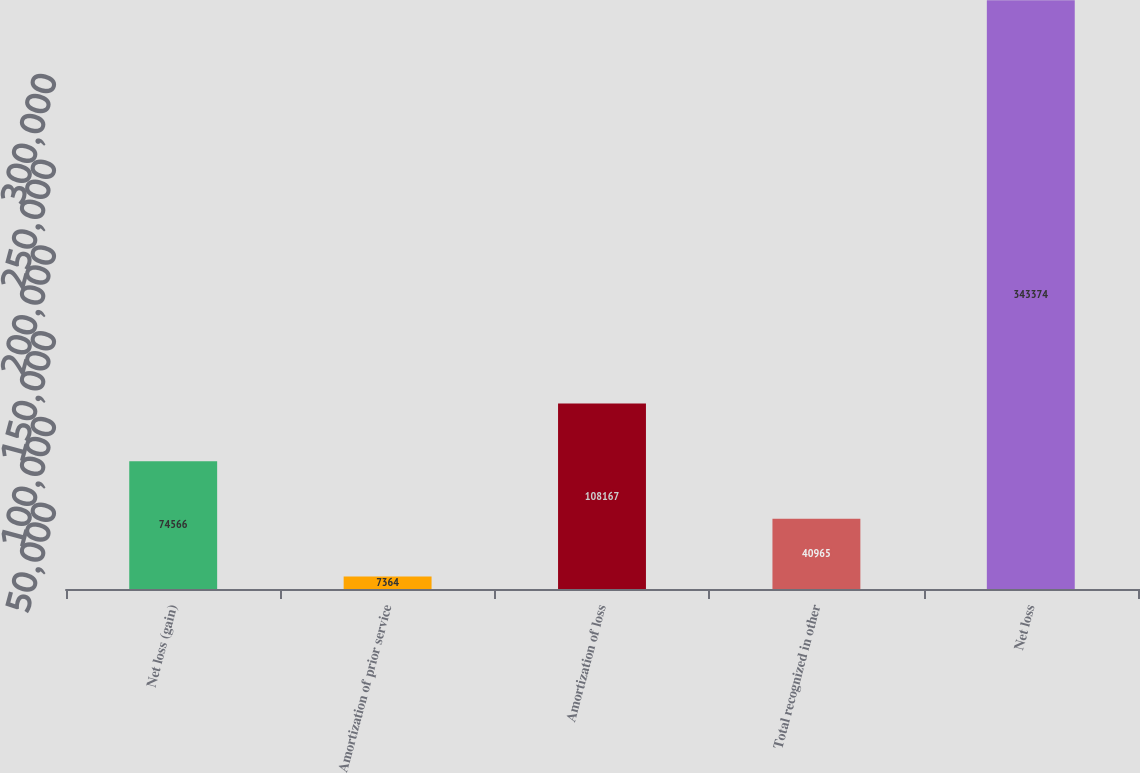<chart> <loc_0><loc_0><loc_500><loc_500><bar_chart><fcel>Net loss (gain)<fcel>Amortization of prior service<fcel>Amortization of loss<fcel>Total recognized in other<fcel>Net loss<nl><fcel>74566<fcel>7364<fcel>108167<fcel>40965<fcel>343374<nl></chart> 